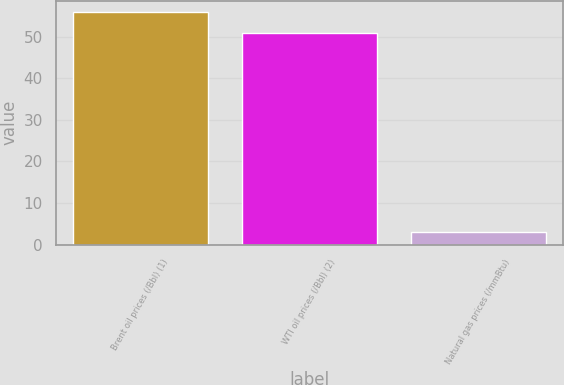Convert chart to OTSL. <chart><loc_0><loc_0><loc_500><loc_500><bar_chart><fcel>Brent oil prices (/Bbl) (1)<fcel>WTI oil prices (/Bbl) (2)<fcel>Natural gas prices (/mmBtu)<nl><fcel>55.91<fcel>50.8<fcel>2.99<nl></chart> 